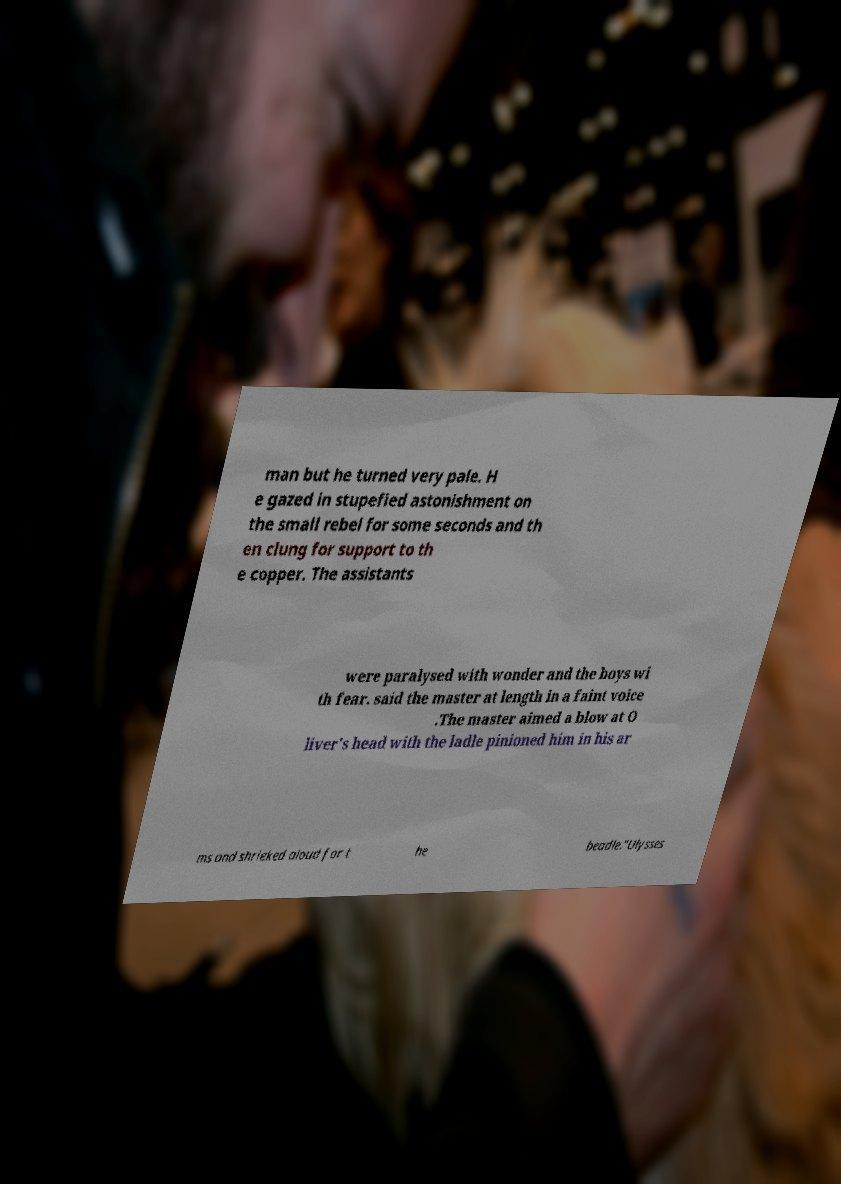Please identify and transcribe the text found in this image. man but he turned very pale. H e gazed in stupefied astonishment on the small rebel for some seconds and th en clung for support to th e copper. The assistants were paralysed with wonder and the boys wi th fear. said the master at length in a faint voice .The master aimed a blow at O liver's head with the ladle pinioned him in his ar ms and shrieked aloud for t he beadle."Ulysses 